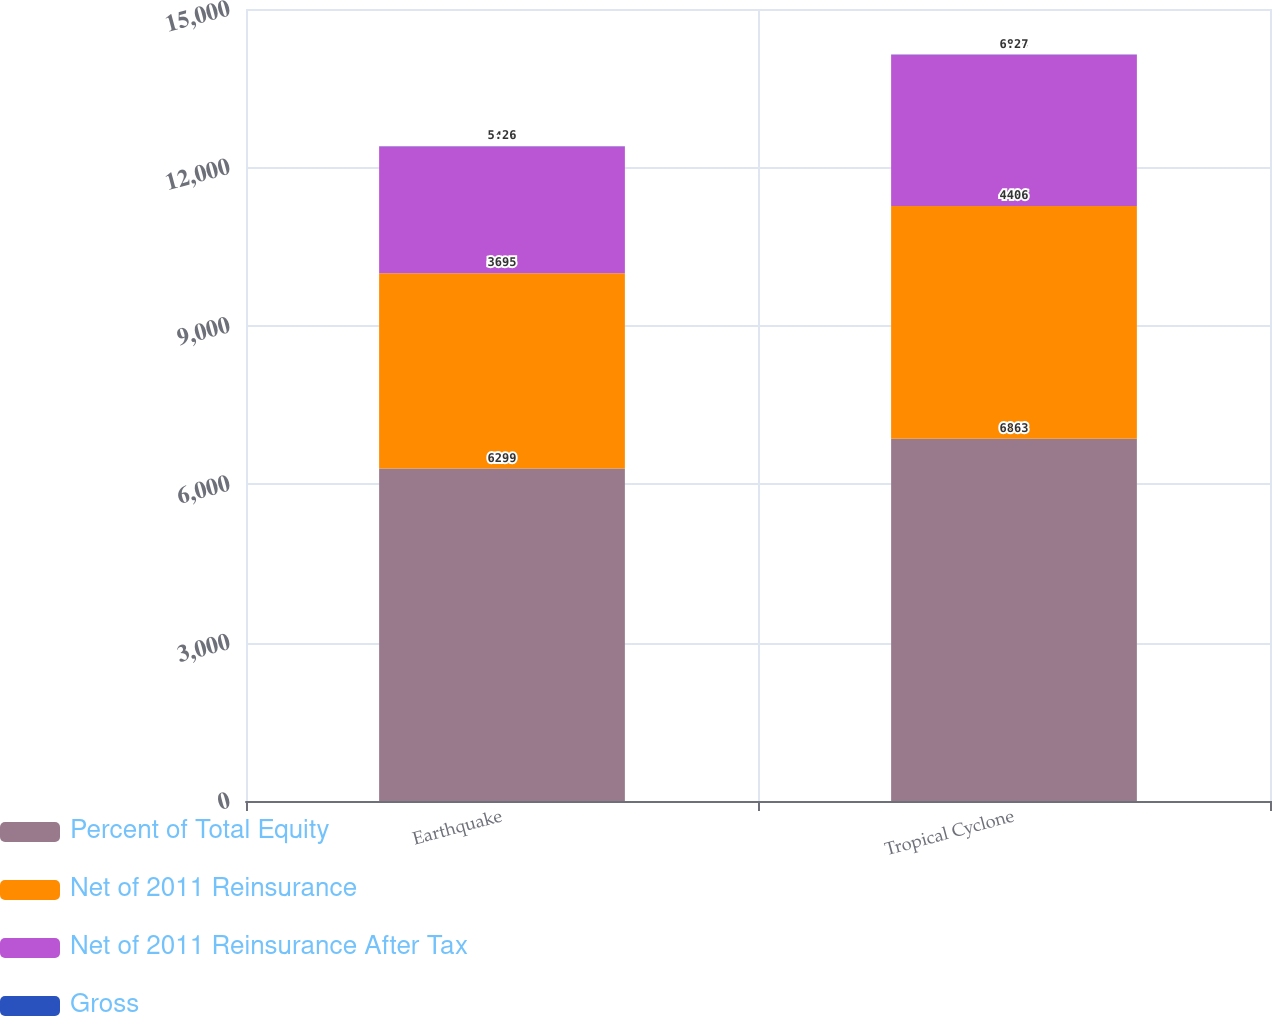Convert chart. <chart><loc_0><loc_0><loc_500><loc_500><stacked_bar_chart><ecel><fcel>Earthquake<fcel>Tropical Cyclone<nl><fcel>Percent of Total Equity<fcel>6299<fcel>6863<nl><fcel>Net of 2011 Reinsurance<fcel>3695<fcel>4406<nl><fcel>Net of 2011 Reinsurance After Tax<fcel>2402<fcel>2864<nl><fcel>Gross<fcel>5.26<fcel>6.27<nl></chart> 